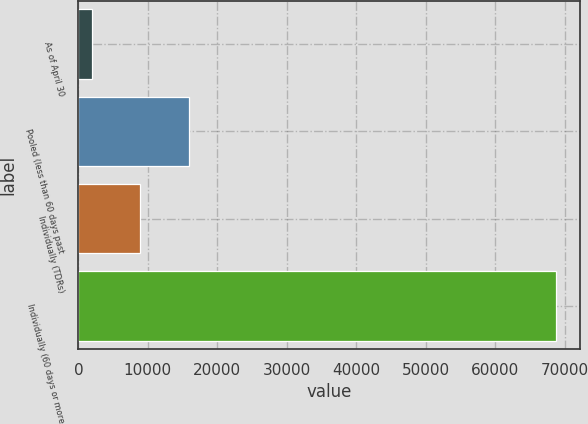<chart> <loc_0><loc_0><loc_500><loc_500><bar_chart><fcel>As of April 30<fcel>Pooled (less than 60 days past<fcel>Individually (TDRs)<fcel>Individually (60 days or more<nl><fcel>2010<fcel>15924<fcel>8915<fcel>68696<nl></chart> 